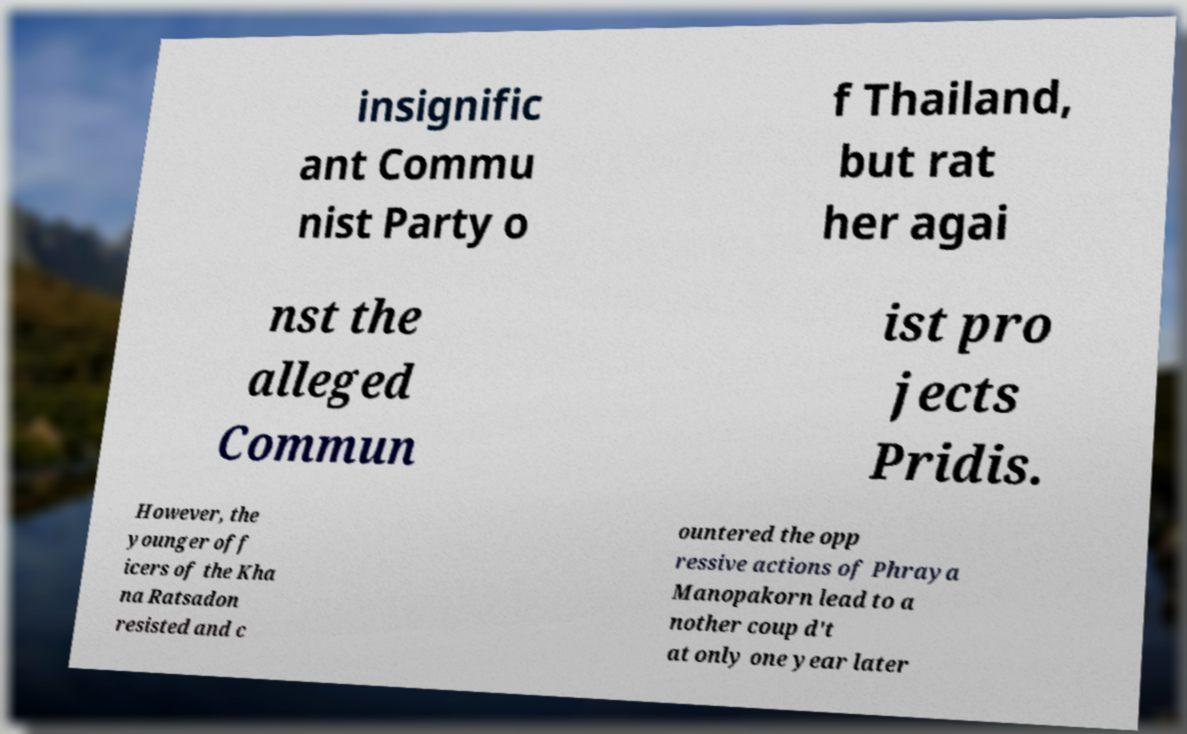I need the written content from this picture converted into text. Can you do that? insignific ant Commu nist Party o f Thailand, but rat her agai nst the alleged Commun ist pro jects Pridis. However, the younger off icers of the Kha na Ratsadon resisted and c ountered the opp ressive actions of Phraya Manopakorn lead to a nother coup d't at only one year later 